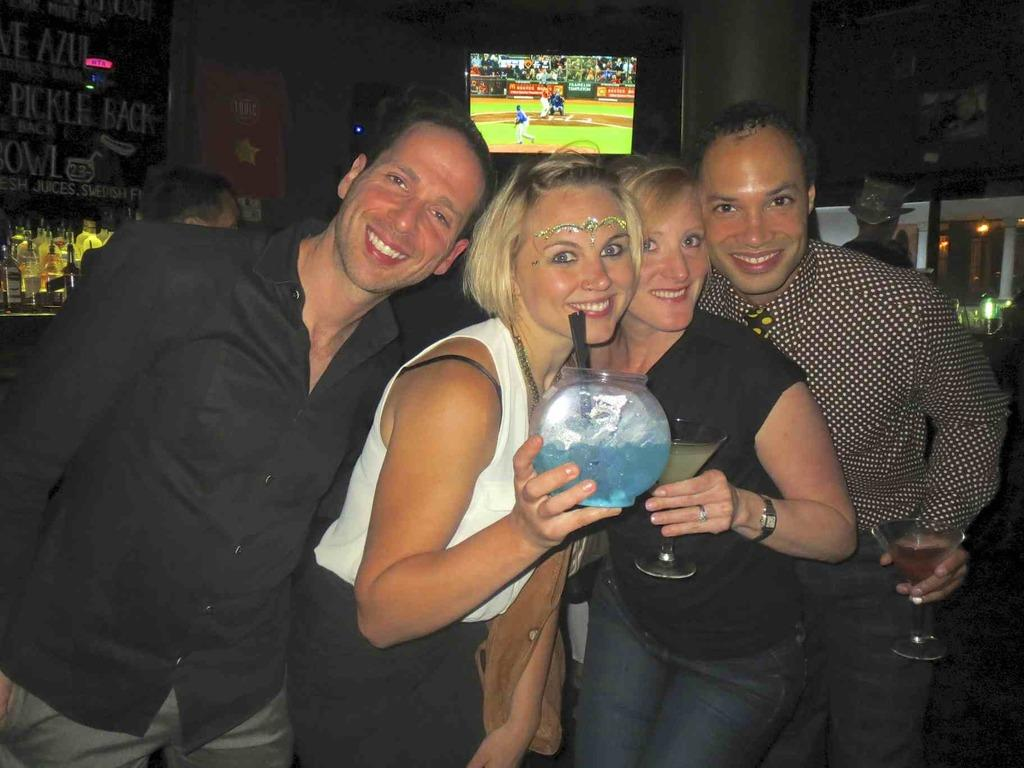How many people are in the image? There are four persons in the image. Can you describe the gender of the people in the image? Two of them are men, and two of them are women. What is one of the women holding in the image? One woman is holding something in the image. Where can bottles be found in the image? Bottles are on the left side of the image. What is located at the top of the image? There is a screen at the top of the image. What type of branch can be seen growing from the screen in the image? There is no branch present in the image, and the screen is not depicted as growing anything. 